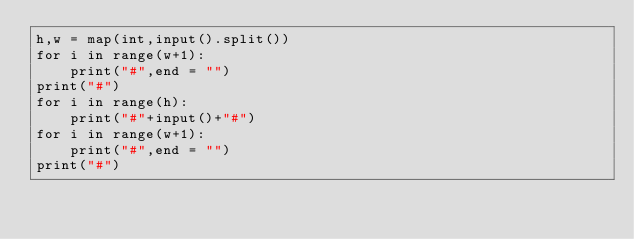<code> <loc_0><loc_0><loc_500><loc_500><_Python_>h,w = map(int,input().split())
for i in range(w+1):
    print("#",end = "")
print("#")
for i in range(h):
    print("#"+input()+"#")
for i in range(w+1):
    print("#",end = "")
print("#")</code> 